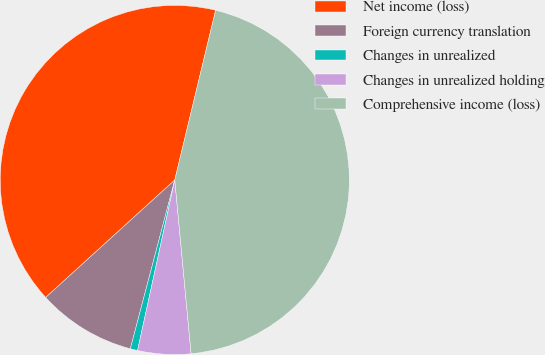Convert chart. <chart><loc_0><loc_0><loc_500><loc_500><pie_chart><fcel>Net income (loss)<fcel>Foreign currency translation<fcel>Changes in unrealized<fcel>Changes in unrealized holding<fcel>Comprehensive income (loss)<nl><fcel>40.51%<fcel>9.15%<fcel>0.68%<fcel>4.91%<fcel>44.75%<nl></chart> 